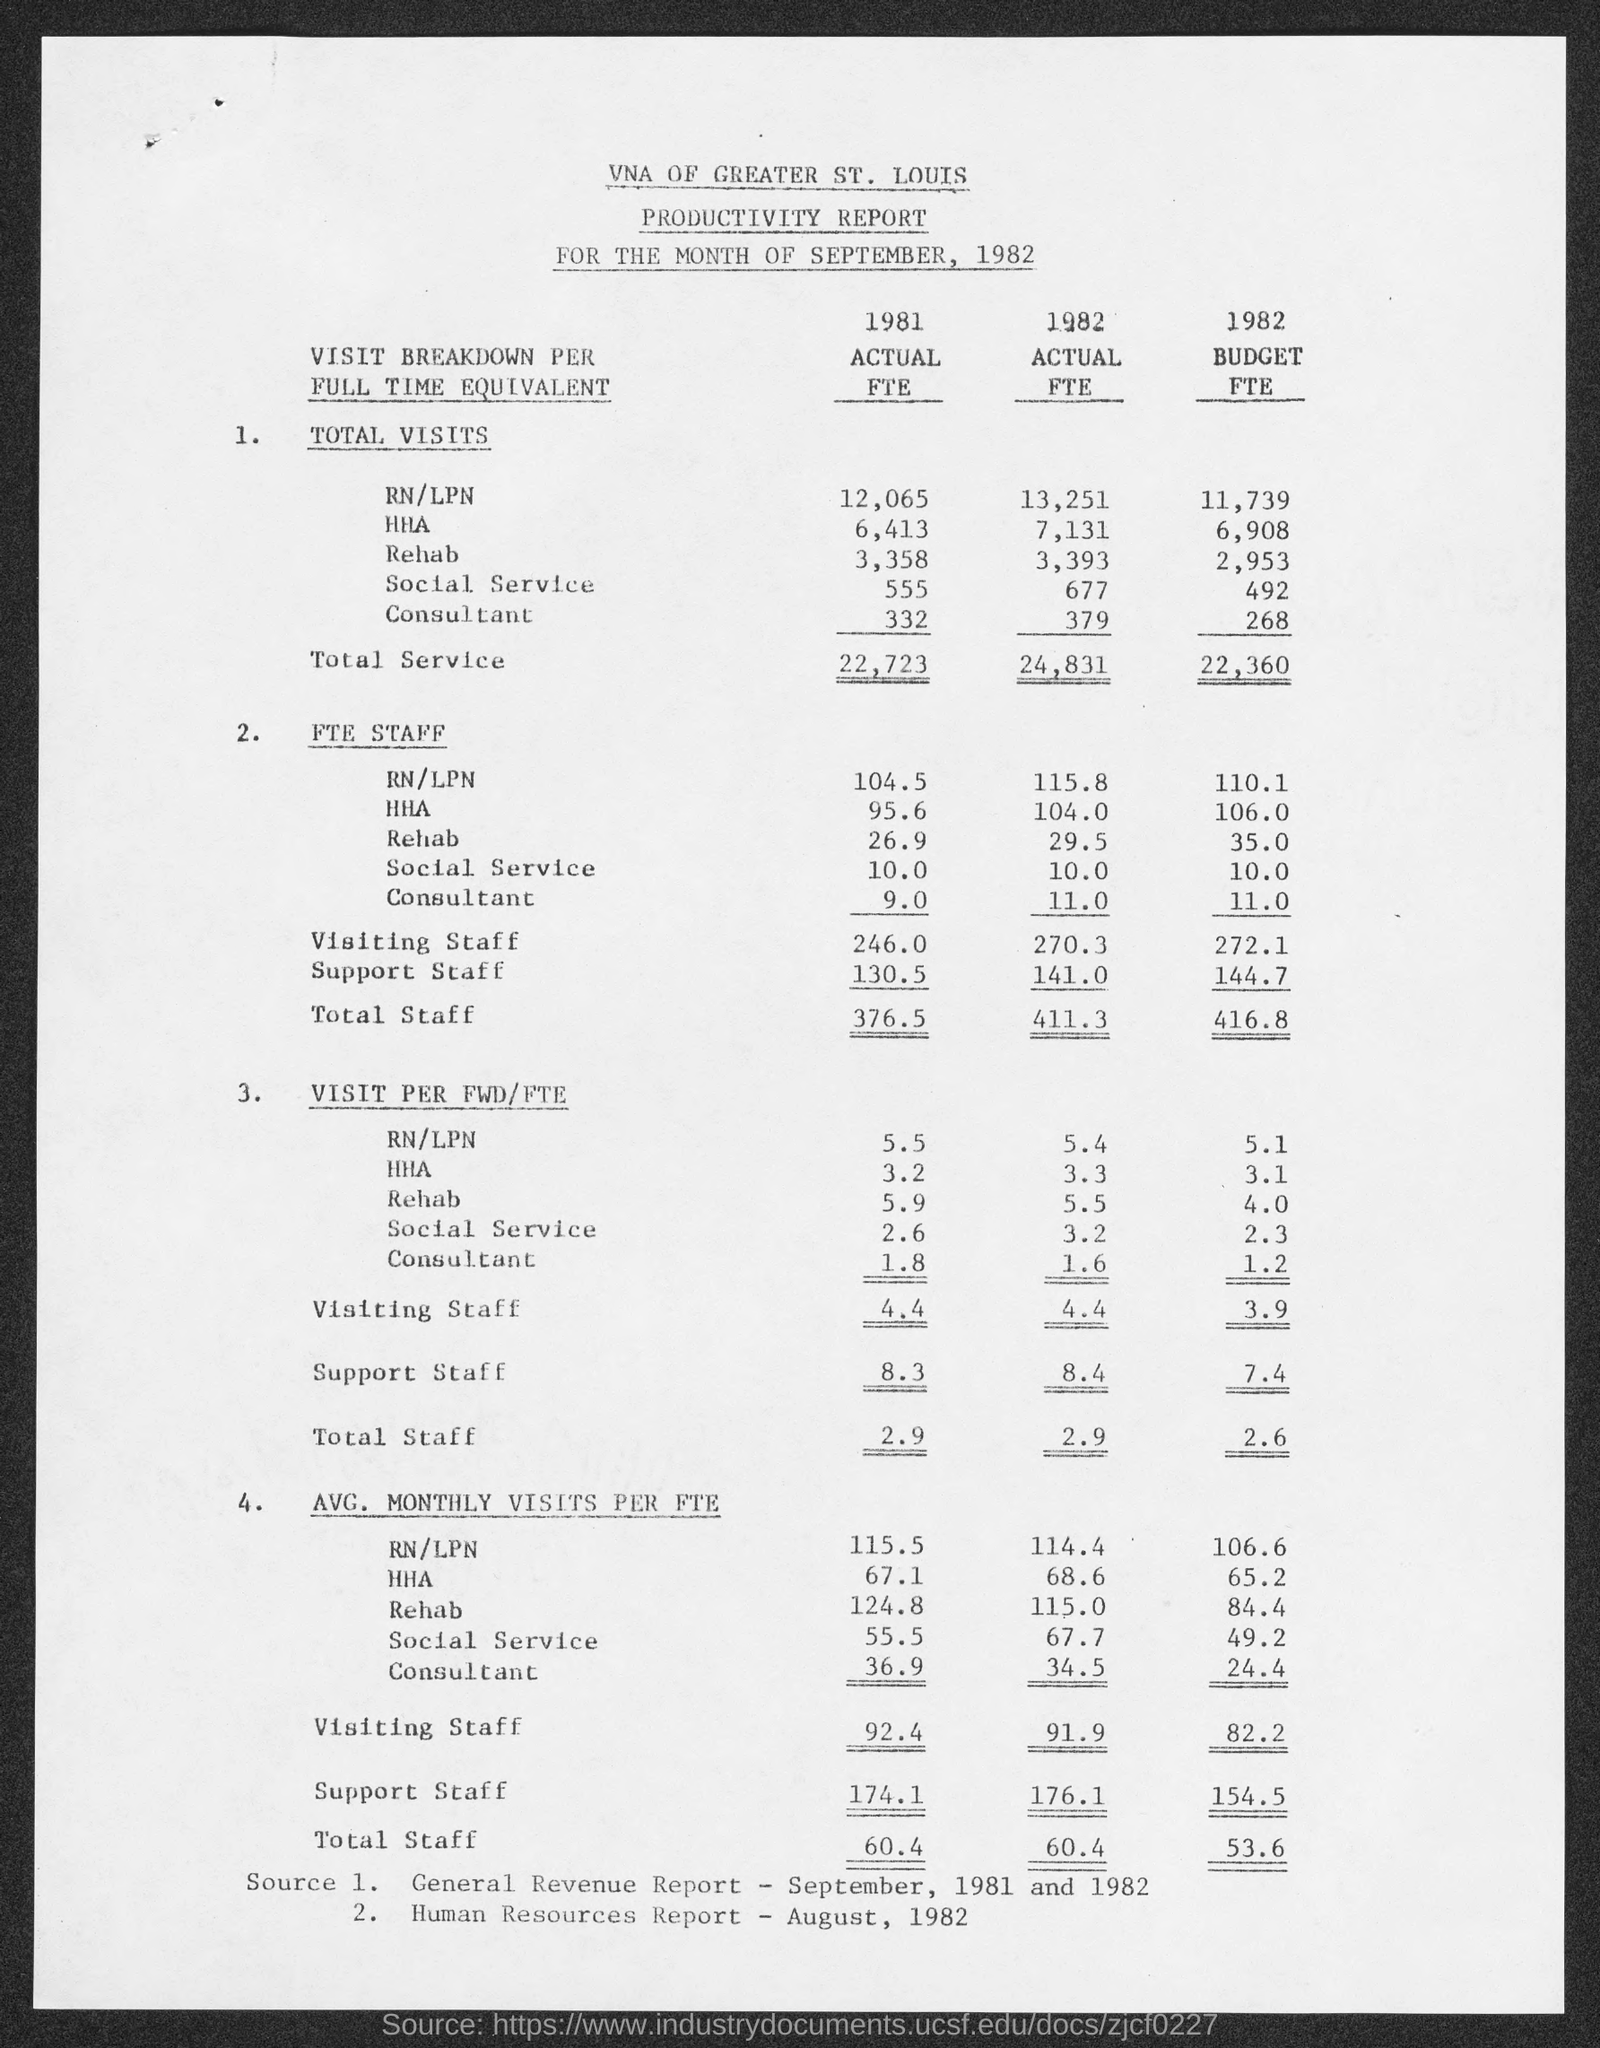What is the avg. number of visiting staff in the year 1981 as mentioned in the given form
Your response must be concise. 92.4. What is the value of total visits of social services in the year 1981 ?
Offer a terse response. 555. What is the value of total visits of rehab in the year 1982 ?
Ensure brevity in your answer.  3,393. What is the value of total service in the year 1981 ?
Provide a succinct answer. 22,723. What is the value of total service in the year 1982 ?
Provide a succinct answer. 24,831. What is the value of total staff in the fte staff in the year 1981 ?
Provide a succinct answer. 376.5. What is the value of total staff in the fte staff in the year 1982 ?
Your answer should be very brief. 411.3. 